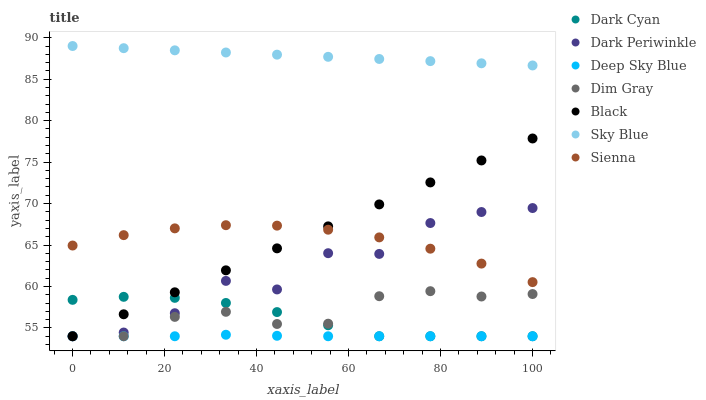Does Deep Sky Blue have the minimum area under the curve?
Answer yes or no. Yes. Does Sky Blue have the maximum area under the curve?
Answer yes or no. Yes. Does Sienna have the minimum area under the curve?
Answer yes or no. No. Does Sienna have the maximum area under the curve?
Answer yes or no. No. Is Sky Blue the smoothest?
Answer yes or no. Yes. Is Dark Periwinkle the roughest?
Answer yes or no. Yes. Is Sienna the smoothest?
Answer yes or no. No. Is Sienna the roughest?
Answer yes or no. No. Does Dim Gray have the lowest value?
Answer yes or no. Yes. Does Sienna have the lowest value?
Answer yes or no. No. Does Sky Blue have the highest value?
Answer yes or no. Yes. Does Sienna have the highest value?
Answer yes or no. No. Is Deep Sky Blue less than Sky Blue?
Answer yes or no. Yes. Is Sky Blue greater than Dim Gray?
Answer yes or no. Yes. Does Dark Periwinkle intersect Sienna?
Answer yes or no. Yes. Is Dark Periwinkle less than Sienna?
Answer yes or no. No. Is Dark Periwinkle greater than Sienna?
Answer yes or no. No. Does Deep Sky Blue intersect Sky Blue?
Answer yes or no. No. 